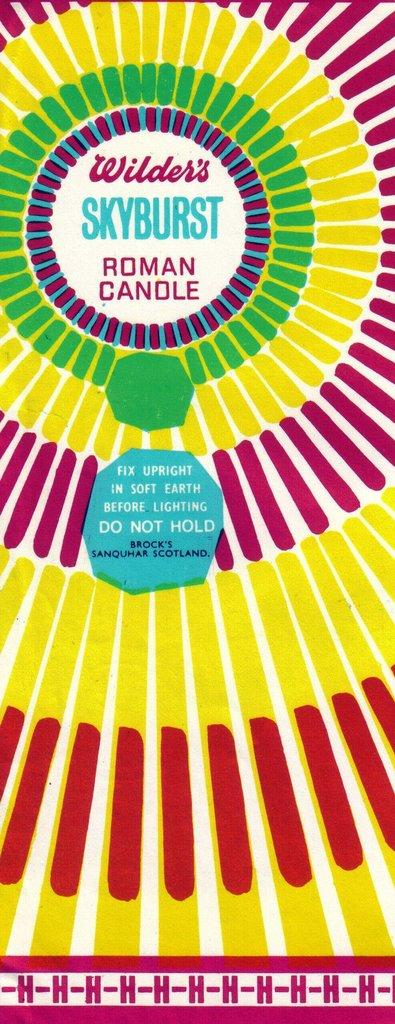Provide a one-sentence caption for the provided image. A label for Wilder's Skyburst Roman Candle has a spiral pattern. 